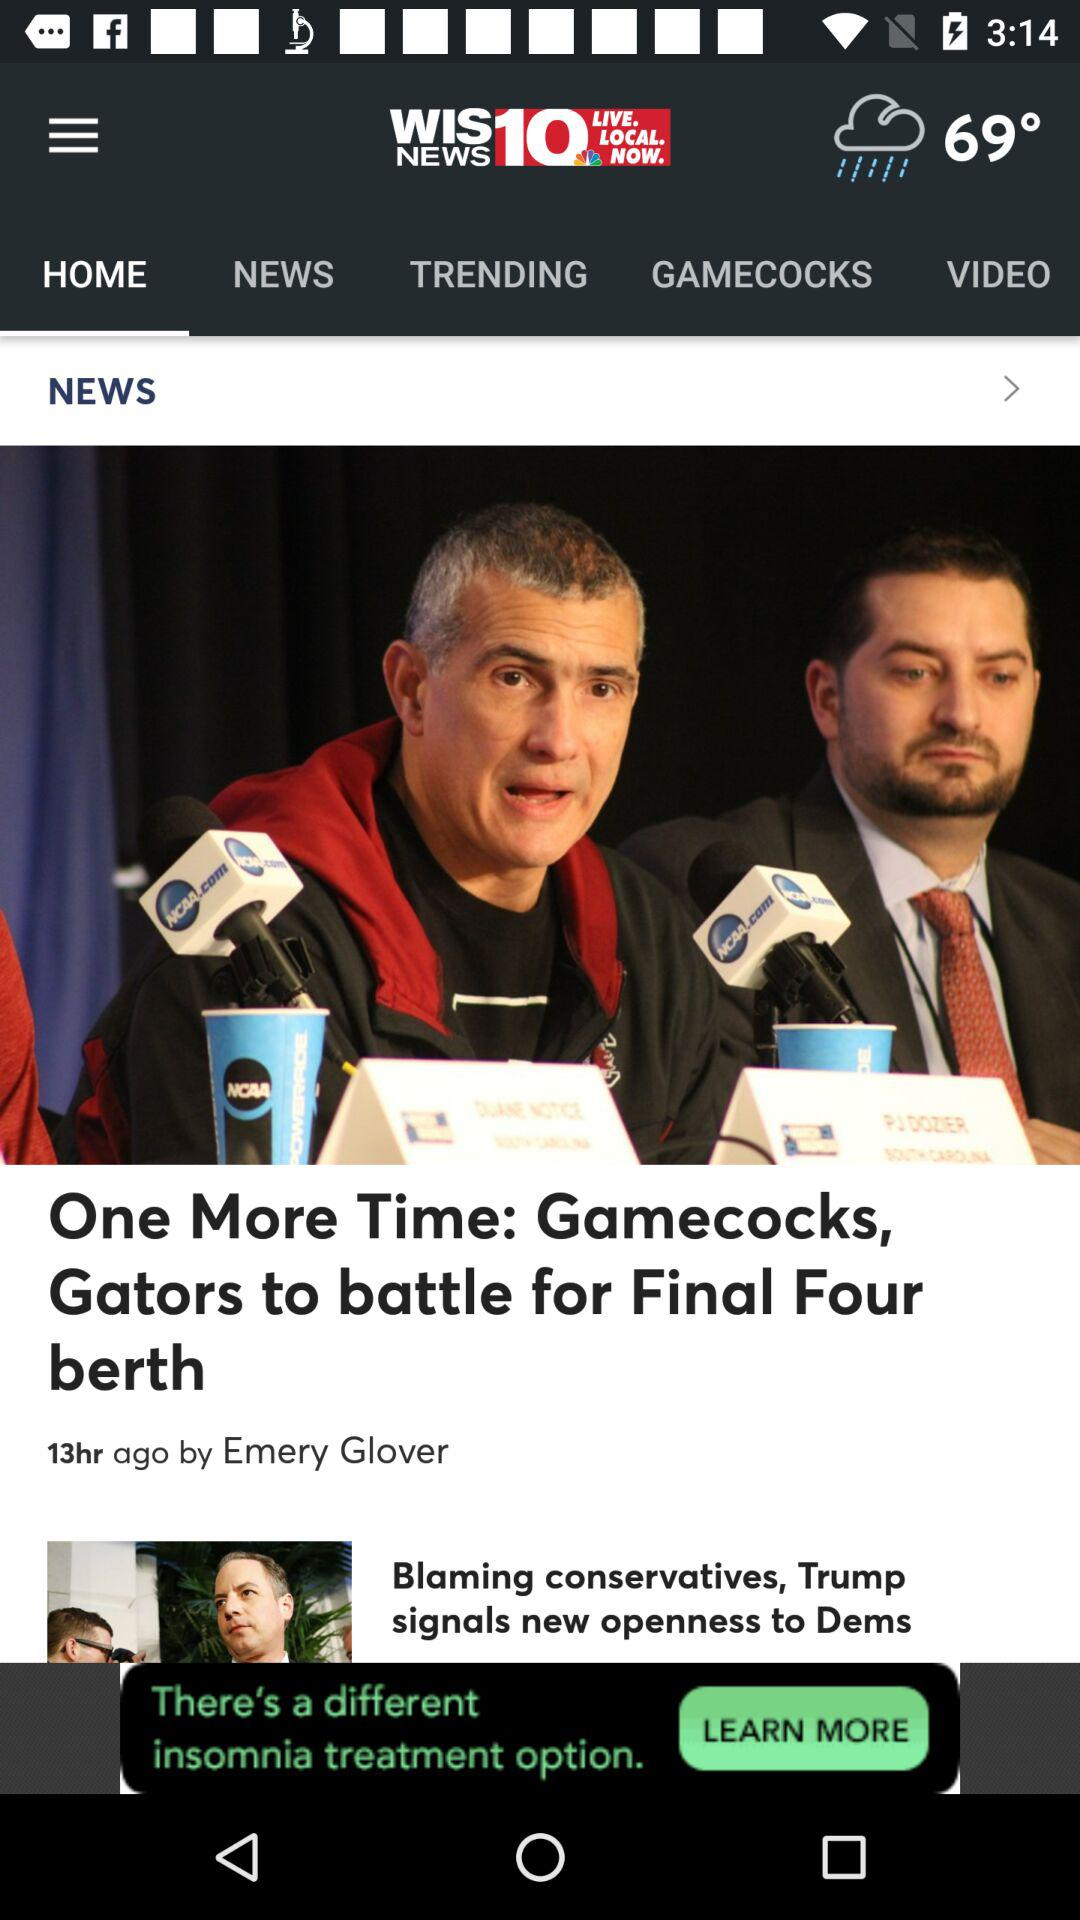Who posted the news "Gamecocks, Gators to battle for Final Four berth"? The news was posted by Emery Glover. 